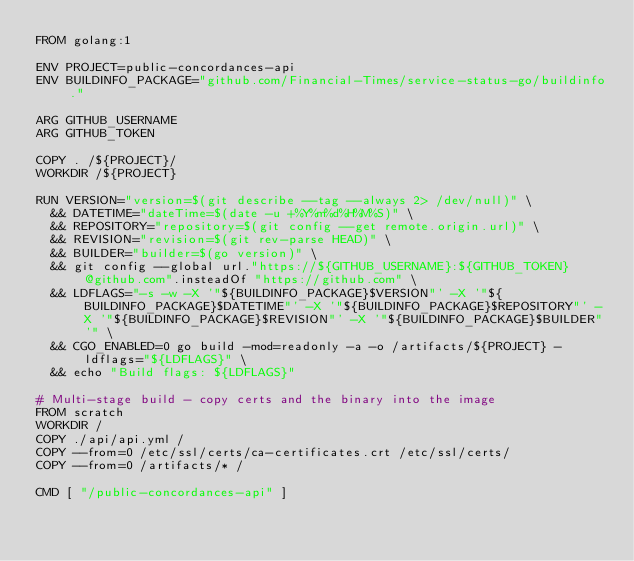<code> <loc_0><loc_0><loc_500><loc_500><_Dockerfile_>FROM golang:1

ENV PROJECT=public-concordances-api
ENV BUILDINFO_PACKAGE="github.com/Financial-Times/service-status-go/buildinfo."

ARG GITHUB_USERNAME
ARG GITHUB_TOKEN

COPY . /${PROJECT}/
WORKDIR /${PROJECT}

RUN VERSION="version=$(git describe --tag --always 2> /dev/null)" \
  && DATETIME="dateTime=$(date -u +%Y%m%d%H%M%S)" \
  && REPOSITORY="repository=$(git config --get remote.origin.url)" \
  && REVISION="revision=$(git rev-parse HEAD)" \
  && BUILDER="builder=$(go version)" \
  && git config --global url."https://${GITHUB_USERNAME}:${GITHUB_TOKEN}@github.com".insteadOf "https://github.com" \
  && LDFLAGS="-s -w -X '"${BUILDINFO_PACKAGE}$VERSION"' -X '"${BUILDINFO_PACKAGE}$DATETIME"' -X '"${BUILDINFO_PACKAGE}$REPOSITORY"' -X '"${BUILDINFO_PACKAGE}$REVISION"' -X '"${BUILDINFO_PACKAGE}$BUILDER"'" \
  && CGO_ENABLED=0 go build -mod=readonly -a -o /artifacts/${PROJECT} -ldflags="${LDFLAGS}" \
  && echo "Build flags: ${LDFLAGS}"

# Multi-stage build - copy certs and the binary into the image
FROM scratch
WORKDIR /
COPY ./api/api.yml /
COPY --from=0 /etc/ssl/certs/ca-certificates.crt /etc/ssl/certs/
COPY --from=0 /artifacts/* /

CMD [ "/public-concordances-api" ]
</code> 